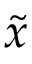<formula> <loc_0><loc_0><loc_500><loc_500>\widetilde { x }</formula> 